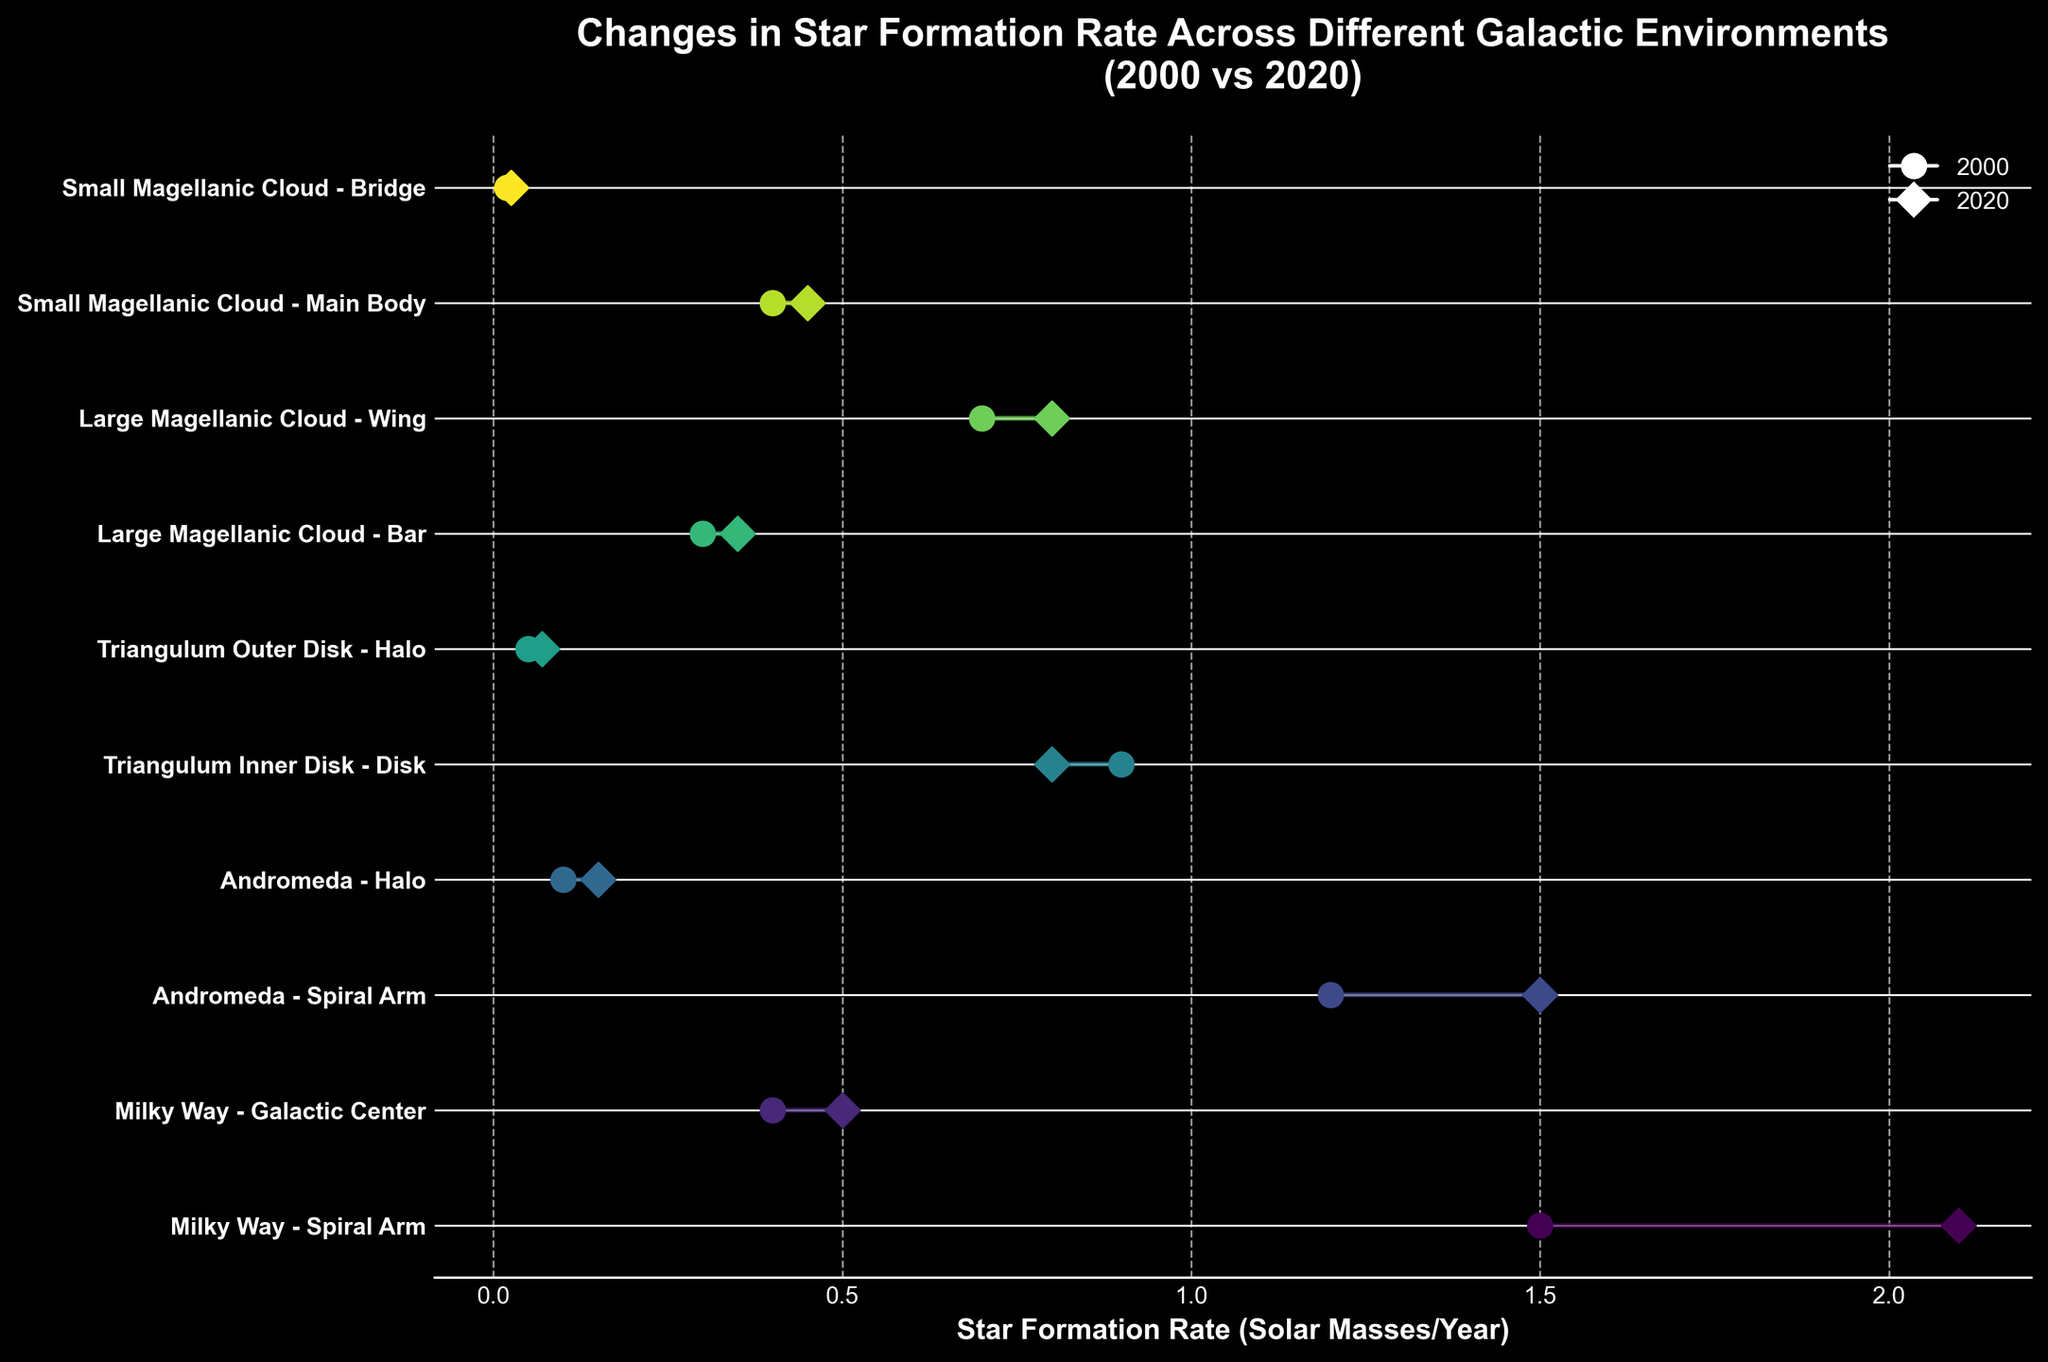What's the title of the figure? The title is usually located at the top of the figure and provides an overview of what the plot is about. In this case, the title given is "Changes in Star Formation Rate Across Different Galactic Environments (2000 vs 2020)."
Answer: Changes in Star Formation Rate Across Different Galactic Environments (2000 vs 2020) Which galactic environment showed the highest increase in star formation rate from 2000 to 2020? By comparing the changes in Star Formation Rate (SFR) from 2000 to 2020 across different environments, we look for the one with the largest difference. The Milky Way's Spiral Arm shows the largest increase from 1.5 to 2.1.
Answer: Milky Way's Spiral Arm What are the x-axis labels describing? The x-axis labels generally describe the units or the type of data being measured. Here, it specifies 'Star Formation Rate (Solar Masses/Year)', indicating it measures the rate at which stars are forming in solar masses per year.
Answer: Star Formation Rate (Solar Masses/Year) Which galaxy's environment had the smallest increase in star formation rate? Looking at the differences between the star formation rates in 2000 and 2020, the environment with the smallest increase can be found. In this case, the Triangulum Inner Disk (Disk) shows a decrease from 0.9 to 0.8, which is actually a reduction not an increase. Therefore, the Small Magellanic Cloud's Bridge has the smallest increase from 0.02 to 0.025.
Answer: Small Magellanic Cloud's Bridge In which environments does the star formation rate in 2020 exceed 1 solar mass per year? By examining the 2020 rates, we identify environments where the rate is above 1. The Milky Way's Spiral Arm (2.1) and Andromeda's Spiral Arm (1.5) both exceed 1 solar mass per year in 2020.
Answer: Milky Way's Spiral Arm, Andromeda's Spiral Arm How many environments show a decrease in star formation rate over the period 2000 to 2020? To determine the number of environments with decreasing SFR, we compare the 2000 rates to the 2020 rates. Only the Triangulum Inner Disk shows a decrease from 0.9 to 0.8.
Answer: 1 Which galaxy's environment shows nearly constant star formation rates from 2000 to 2020? Assessing the data for minimal changes between the years, the environments with nearly consistent rates are identified. The Milky Way's Galactic Center is almost constant, changing minutely from 0.4 to 0.5.
Answer: Milky Way's Galactic Center What is the general trend observed in the star formation rates across different galactic environments from 2000 to 2020? Summarizing the overall visual trend, we see whether rates are generally increasing, decreasing, or constant. Most environments show an upward trend in star formation rates over this period.
Answer: Increasing What is the total star formation rate across all environments for the year 2000? To find the total SFR for 2000, we sum the rates for all environments: 1.5 + 0.4 + 1.2 + 0.1 + 0.9 + 0.05 + 0.3 + 0.7 + 0.4 + 0.02 = 5.57.
Answer: 5.57 What is the average change in star formation rate from 2000 to 2020 across all environments? Calculating the average change involves determining the change for each environment and then averaging these values. Changes are: (2.1-1.5), (0.5-0.4), (1.5-1.2), (0.15-0.1), (0.8-0.9), (0.07-0.05), (0.35-0.3), (0.8-0.7), (0.45-0.4), (0.025-0.02). Adding these up: 0.6 + 0.1 + 0.3 + 0.05 - 0.1 + 0.02 + 0.05 + 0.1 + 0.05 + 0.005 = 1.18. Average: 1.18/10 = 0.118.
Answer: 0.118 